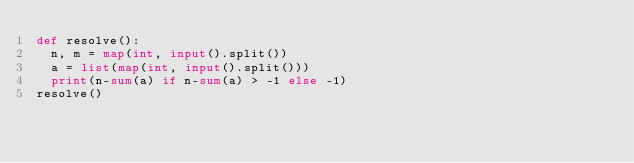Convert code to text. <code><loc_0><loc_0><loc_500><loc_500><_Python_>def resolve():
	n, m = map(int, input().split())
	a = list(map(int, input().split()))
	print(n-sum(a) if n-sum(a) > -1 else -1)
resolve()</code> 